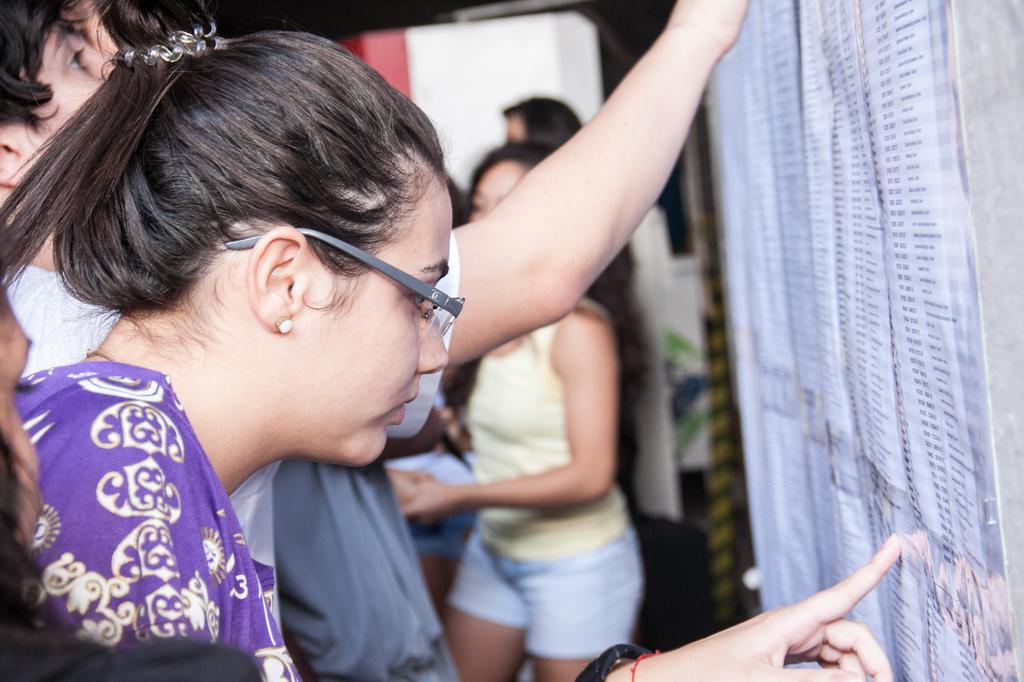How many people are in the image? The number of people in the image is not specified, but there are people present. What are the people doing in the image? The people are standing in front of a notice board. What might be the purpose of the notice board in the image? The notice board might be displaying information or announcements for the people in the image. What type of bushes can be seen growing around the people in the image? There is no mention of bushes in the image, so we cannot determine if any are present. 